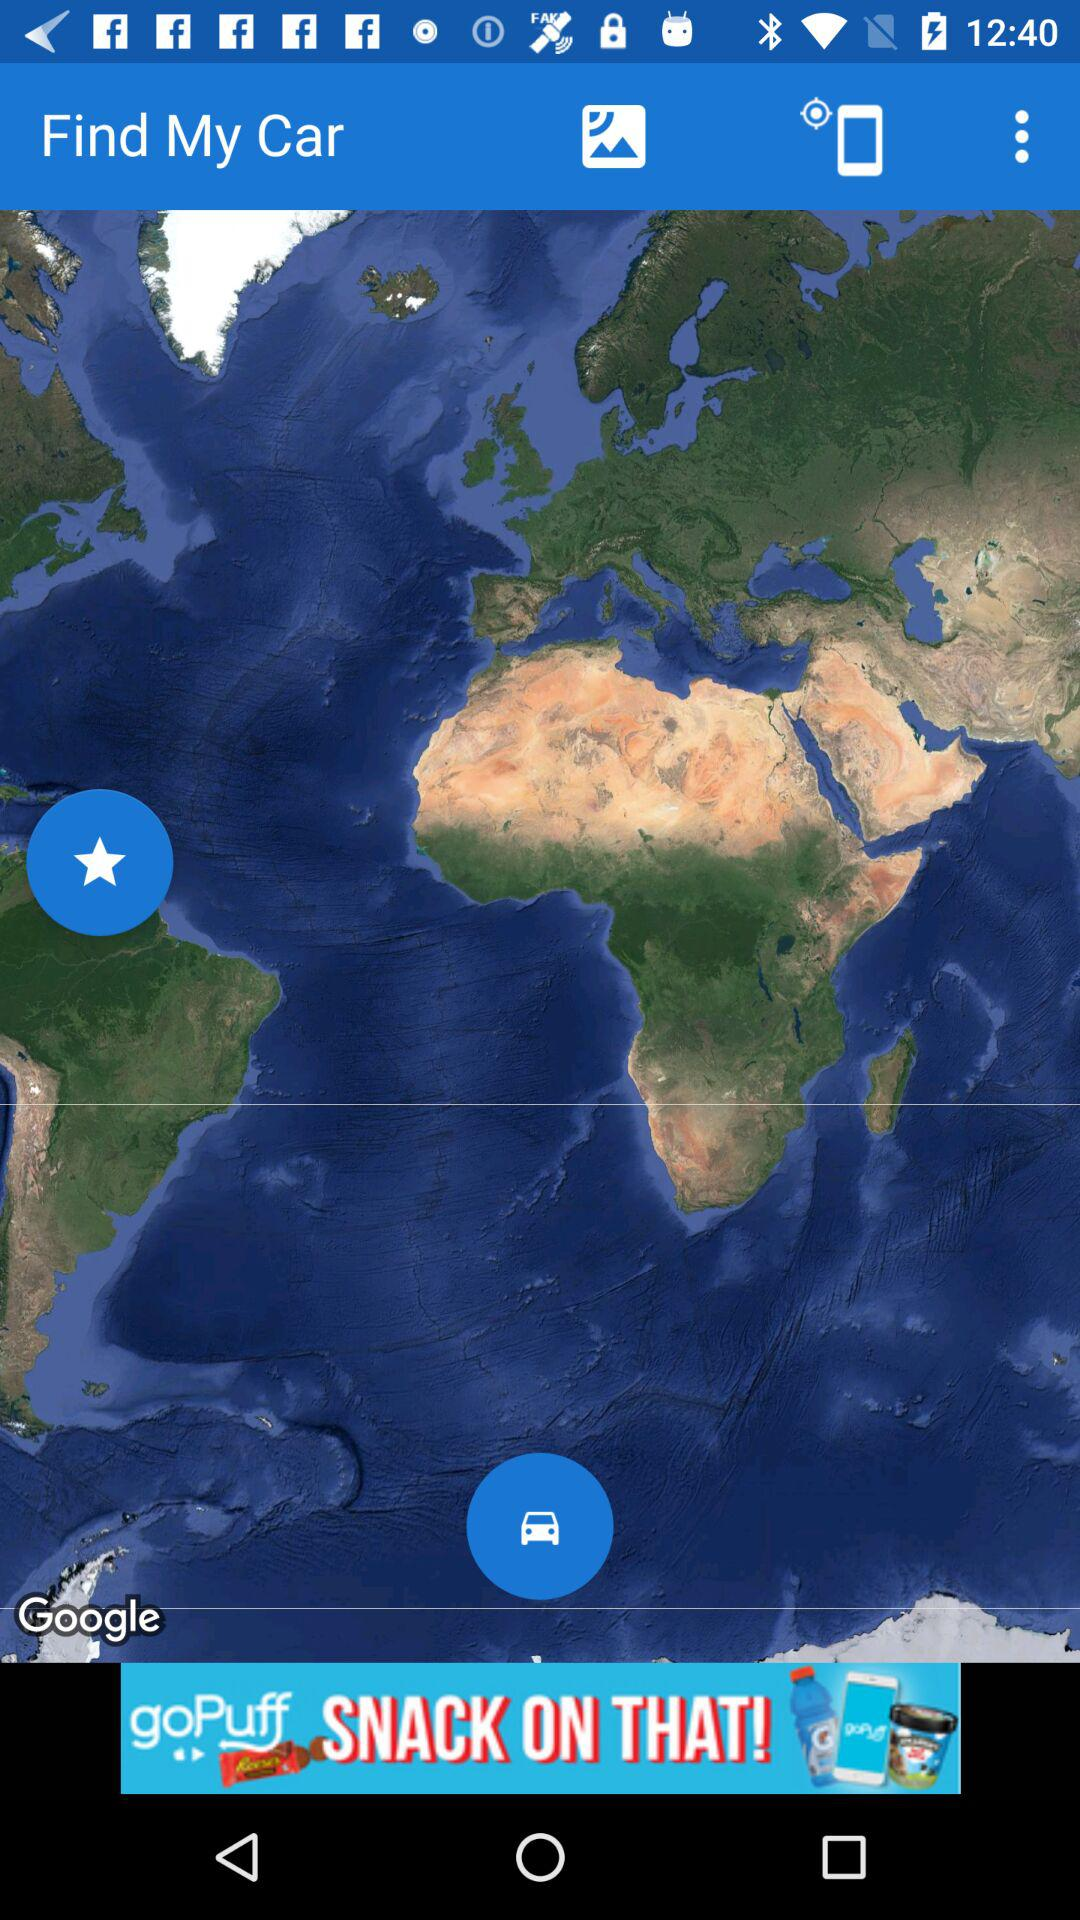What is the name of the application? The name of the application is "Find My Car". 